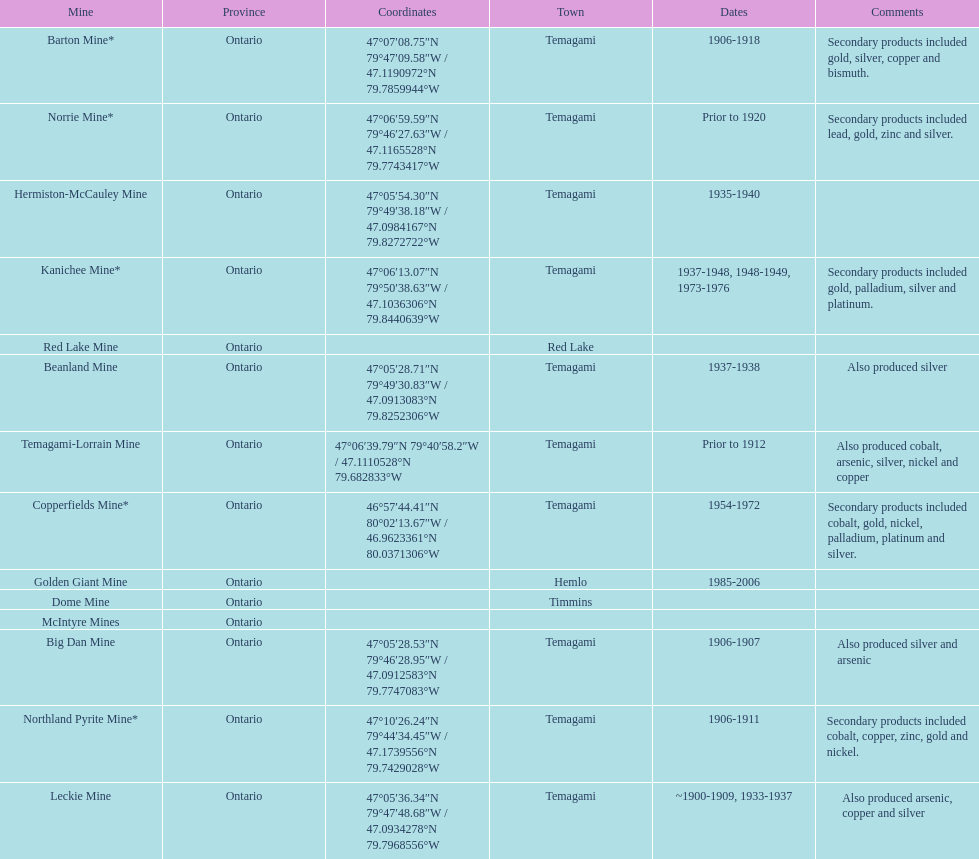What are all the mines with dates listed? Barton Mine*, Beanland Mine, Big Dan Mine, Copperfields Mine*, Golden Giant Mine, Hermiston-McCauley Mine, Kanichee Mine*, Leckie Mine, Norrie Mine*, Northland Pyrite Mine*, Temagami-Lorrain Mine. Which of those dates include the year that the mine was closed? 1906-1918, 1937-1938, 1906-1907, 1954-1972, 1985-2006, 1935-1940, 1937-1948, 1948-1949, 1973-1976, ~1900-1909, 1933-1937, 1906-1911. Which of those mines were opened the longest? Golden Giant Mine. 